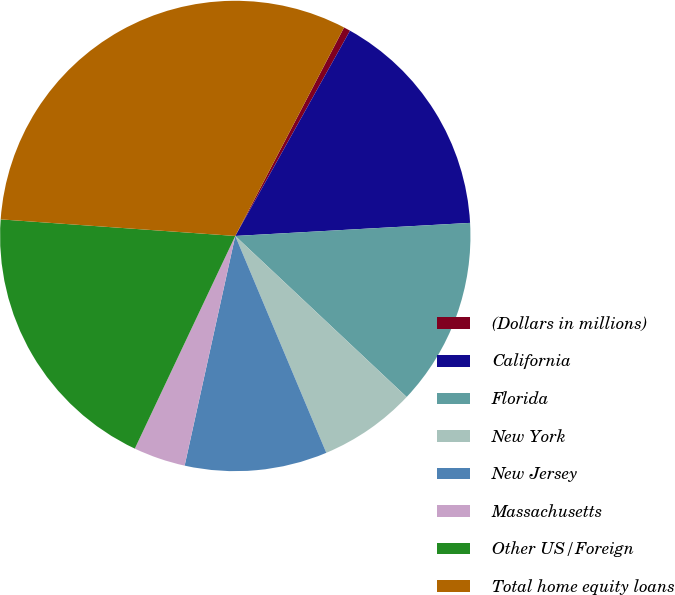<chart> <loc_0><loc_0><loc_500><loc_500><pie_chart><fcel>(Dollars in millions)<fcel>California<fcel>Florida<fcel>New York<fcel>New Jersey<fcel>Massachusetts<fcel>Other US/Foreign<fcel>Total home equity loans<nl><fcel>0.46%<fcel>16.0%<fcel>12.89%<fcel>6.67%<fcel>9.78%<fcel>3.57%<fcel>19.1%<fcel>31.53%<nl></chart> 